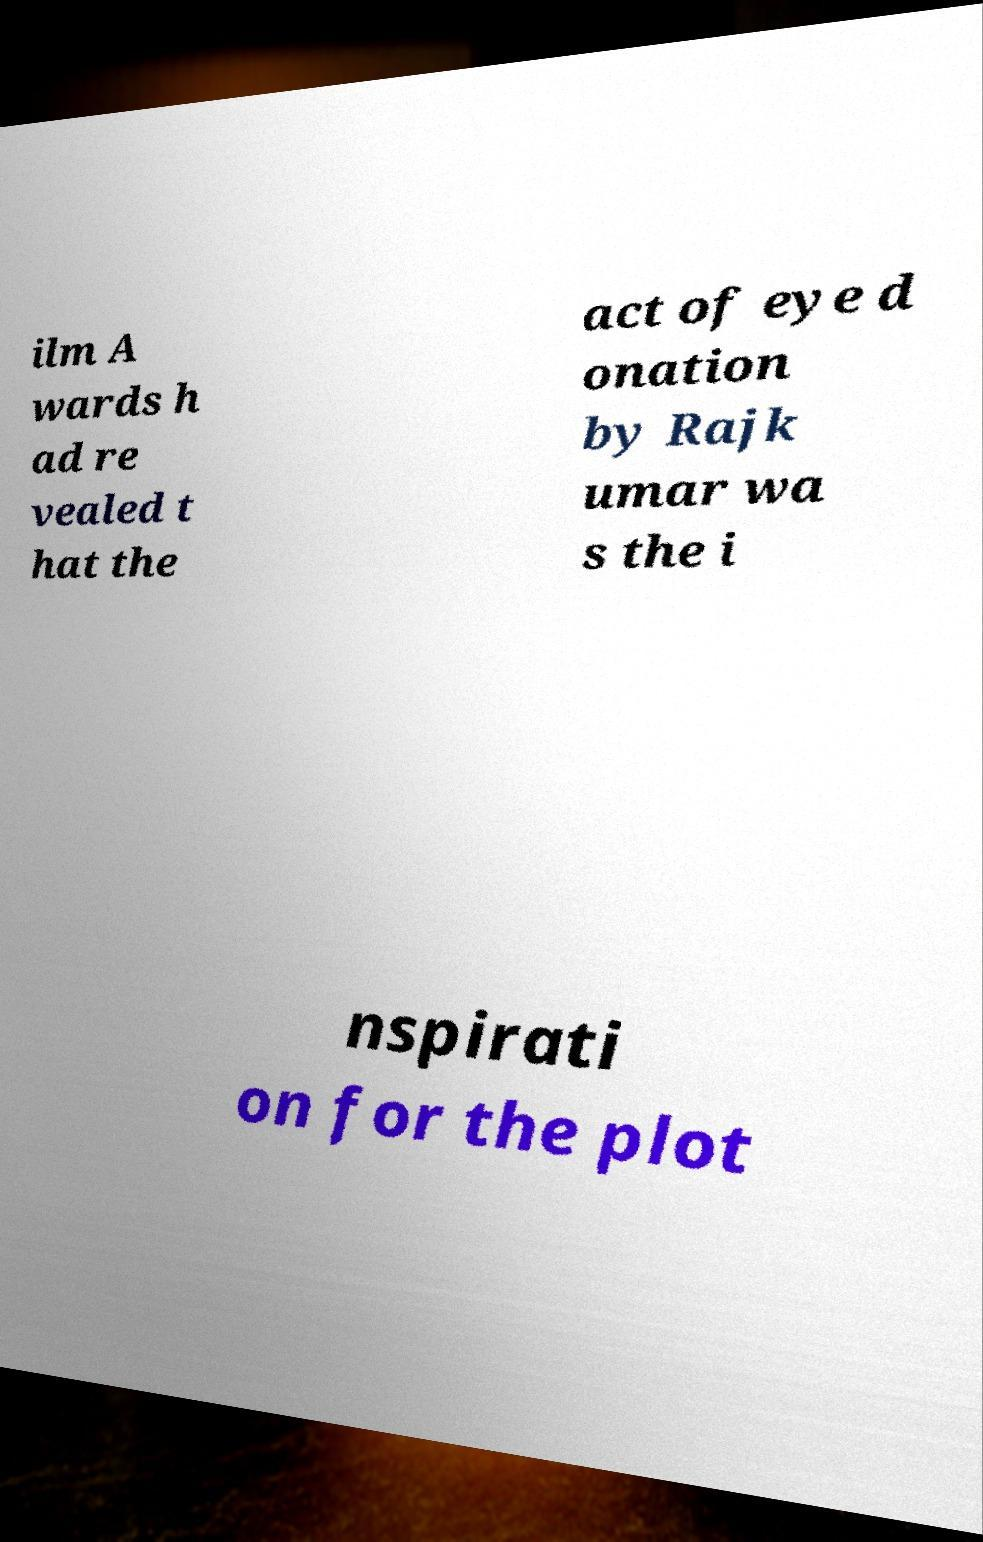What messages or text are displayed in this image? I need them in a readable, typed format. ilm A wards h ad re vealed t hat the act of eye d onation by Rajk umar wa s the i nspirati on for the plot 